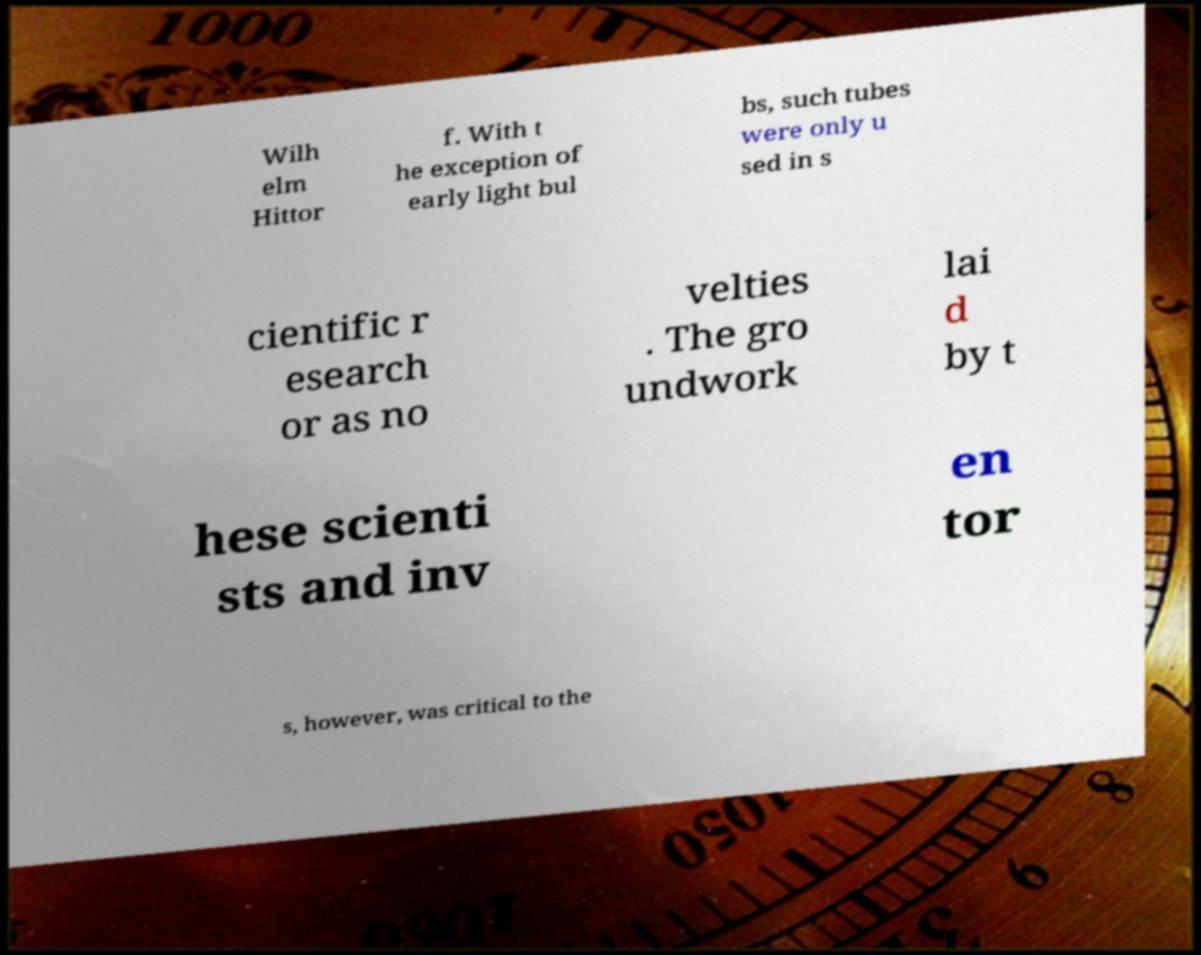Could you assist in decoding the text presented in this image and type it out clearly? Wilh elm Hittor f. With t he exception of early light bul bs, such tubes were only u sed in s cientific r esearch or as no velties . The gro undwork lai d by t hese scienti sts and inv en tor s, however, was critical to the 